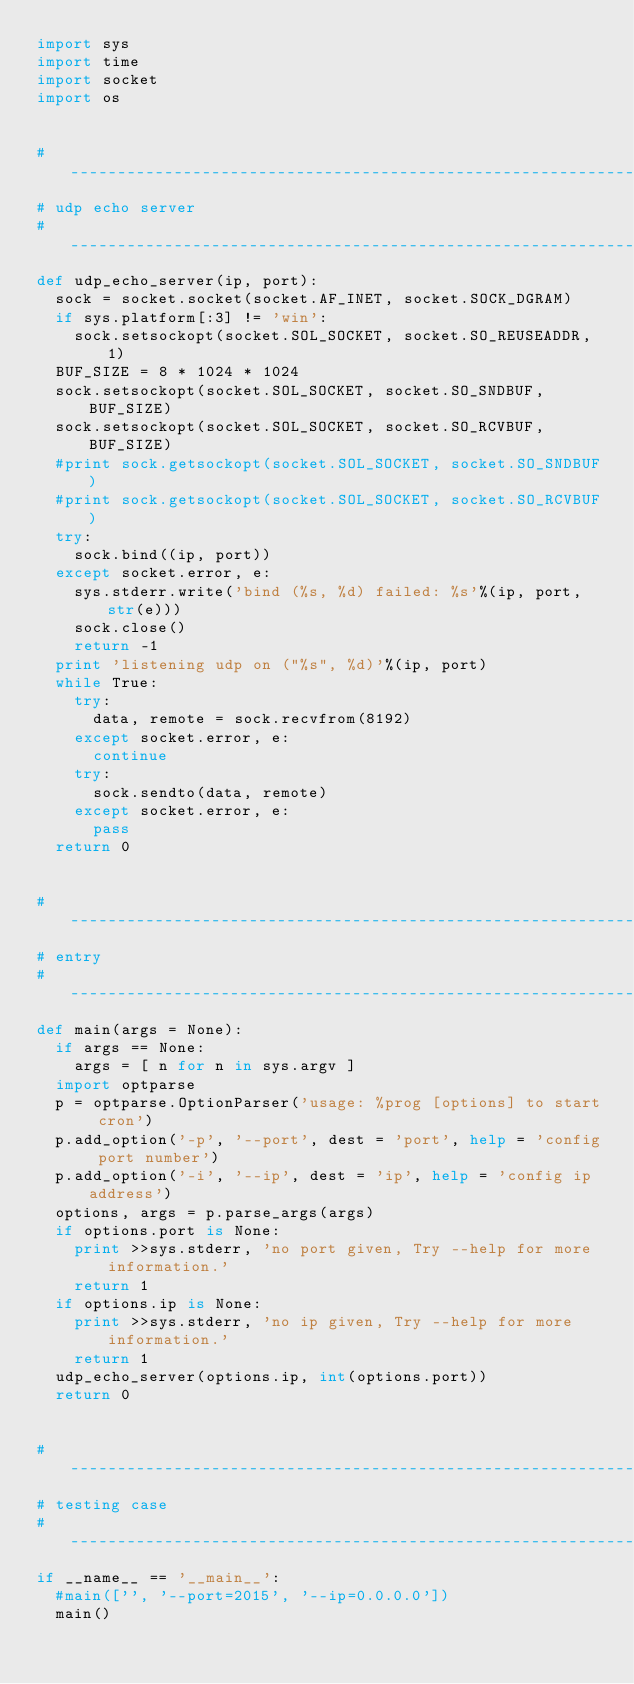<code> <loc_0><loc_0><loc_500><loc_500><_Python_>import sys
import time
import socket
import os


#----------------------------------------------------------------------
# udp echo server
#----------------------------------------------------------------------
def udp_echo_server(ip, port):
	sock = socket.socket(socket.AF_INET, socket.SOCK_DGRAM)
	if sys.platform[:3] != 'win':
		sock.setsockopt(socket.SOL_SOCKET, socket.SO_REUSEADDR, 1)
	BUF_SIZE = 8 * 1024 * 1024
	sock.setsockopt(socket.SOL_SOCKET, socket.SO_SNDBUF, BUF_SIZE) 
	sock.setsockopt(socket.SOL_SOCKET, socket.SO_RCVBUF, BUF_SIZE) 
	#print sock.getsockopt(socket.SOL_SOCKET, socket.SO_SNDBUF)  
	#print sock.getsockopt(socket.SOL_SOCKET, socket.SO_RCVBUF)  
	try:
		sock.bind((ip, port))
	except socket.error, e:
		sys.stderr.write('bind (%s, %d) failed: %s'%(ip, port, str(e)))
		sock.close()
		return -1
	print 'listening udp on ("%s", %d)'%(ip, port)
	while True:
		try:
			data, remote = sock.recvfrom(8192)
		except socket.error, e:
			continue
		try:
			sock.sendto(data, remote)
		except socket.error, e:
			pass
	return 0


#----------------------------------------------------------------------
# entry
#----------------------------------------------------------------------
def main(args = None):
	if args == None:
		args = [ n for n in sys.argv ]
	import optparse
	p = optparse.OptionParser('usage: %prog [options] to start cron')
	p.add_option('-p', '--port', dest = 'port', help = 'config port number')
	p.add_option('-i', '--ip', dest = 'ip', help = 'config ip address')
	options, args = p.parse_args(args) 
	if options.port is None:
		print >>sys.stderr, 'no port given, Try --help for more information.'
		return 1
	if options.ip is None:
		print >>sys.stderr, 'no ip given, Try --help for more information.'
		return 1
	udp_echo_server(options.ip, int(options.port))
	return 0


#----------------------------------------------------------------------
# testing case
#----------------------------------------------------------------------
if __name__ == '__main__':
	#main(['', '--port=2015', '--ip=0.0.0.0'])
	main()

</code> 